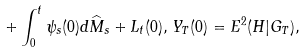<formula> <loc_0><loc_0><loc_500><loc_500>+ \int _ { 0 } ^ { t } \psi _ { s } ( 0 ) d \widehat { M } _ { s } + L _ { t } ( 0 ) , \, Y _ { T } ( 0 ) = E ^ { 2 } ( H | G _ { T } ) ,</formula> 